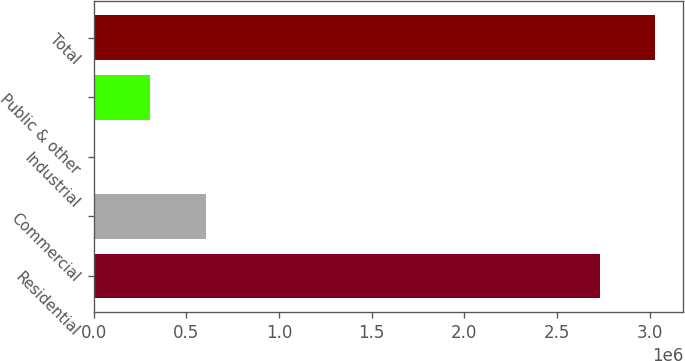Convert chart. <chart><loc_0><loc_0><loc_500><loc_500><bar_chart><fcel>Residential<fcel>Commercial<fcel>Industrial<fcel>Public & other<fcel>Total<nl><fcel>2.73052e+06<fcel>603214<fcel>3885<fcel>303549<fcel>3.03019e+06<nl></chart> 